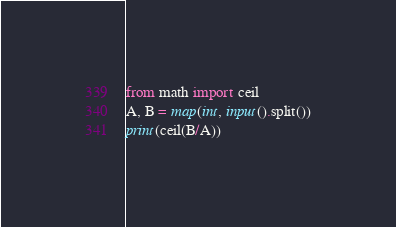Convert code to text. <code><loc_0><loc_0><loc_500><loc_500><_Python_>from math import ceil
A, B = map(int, input().split())
print(ceil(B/A))</code> 